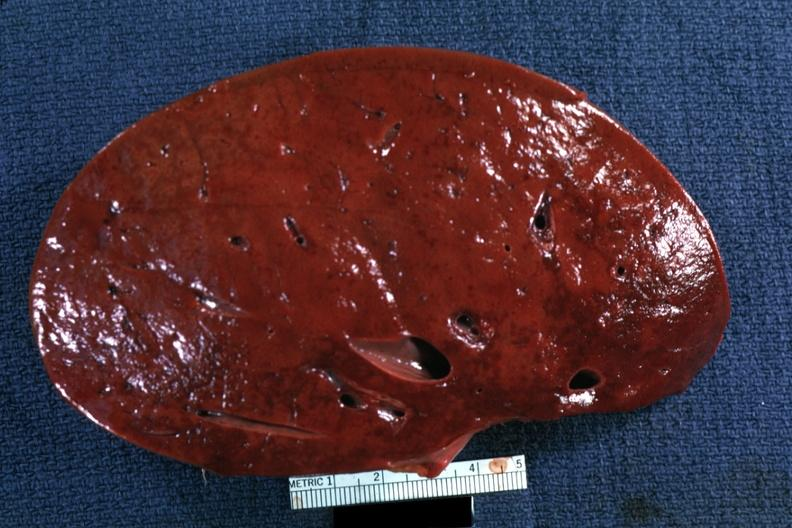what is present?
Answer the question using a single word or phrase. Spleen 